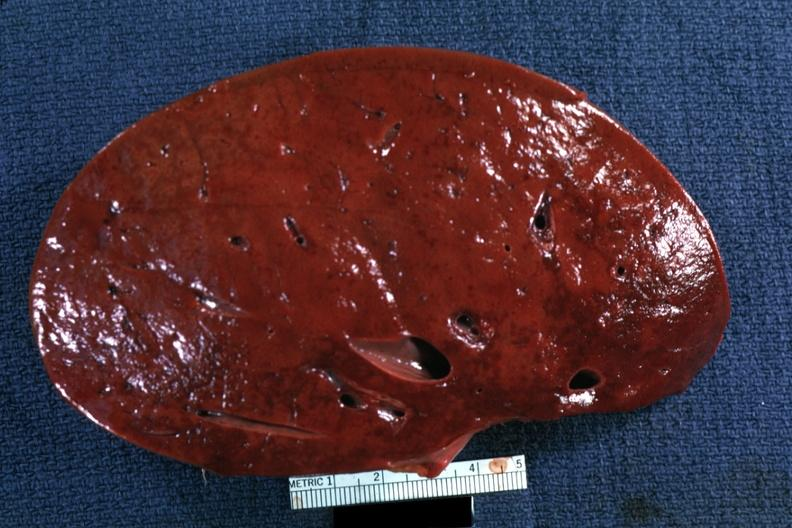what is present?
Answer the question using a single word or phrase. Spleen 